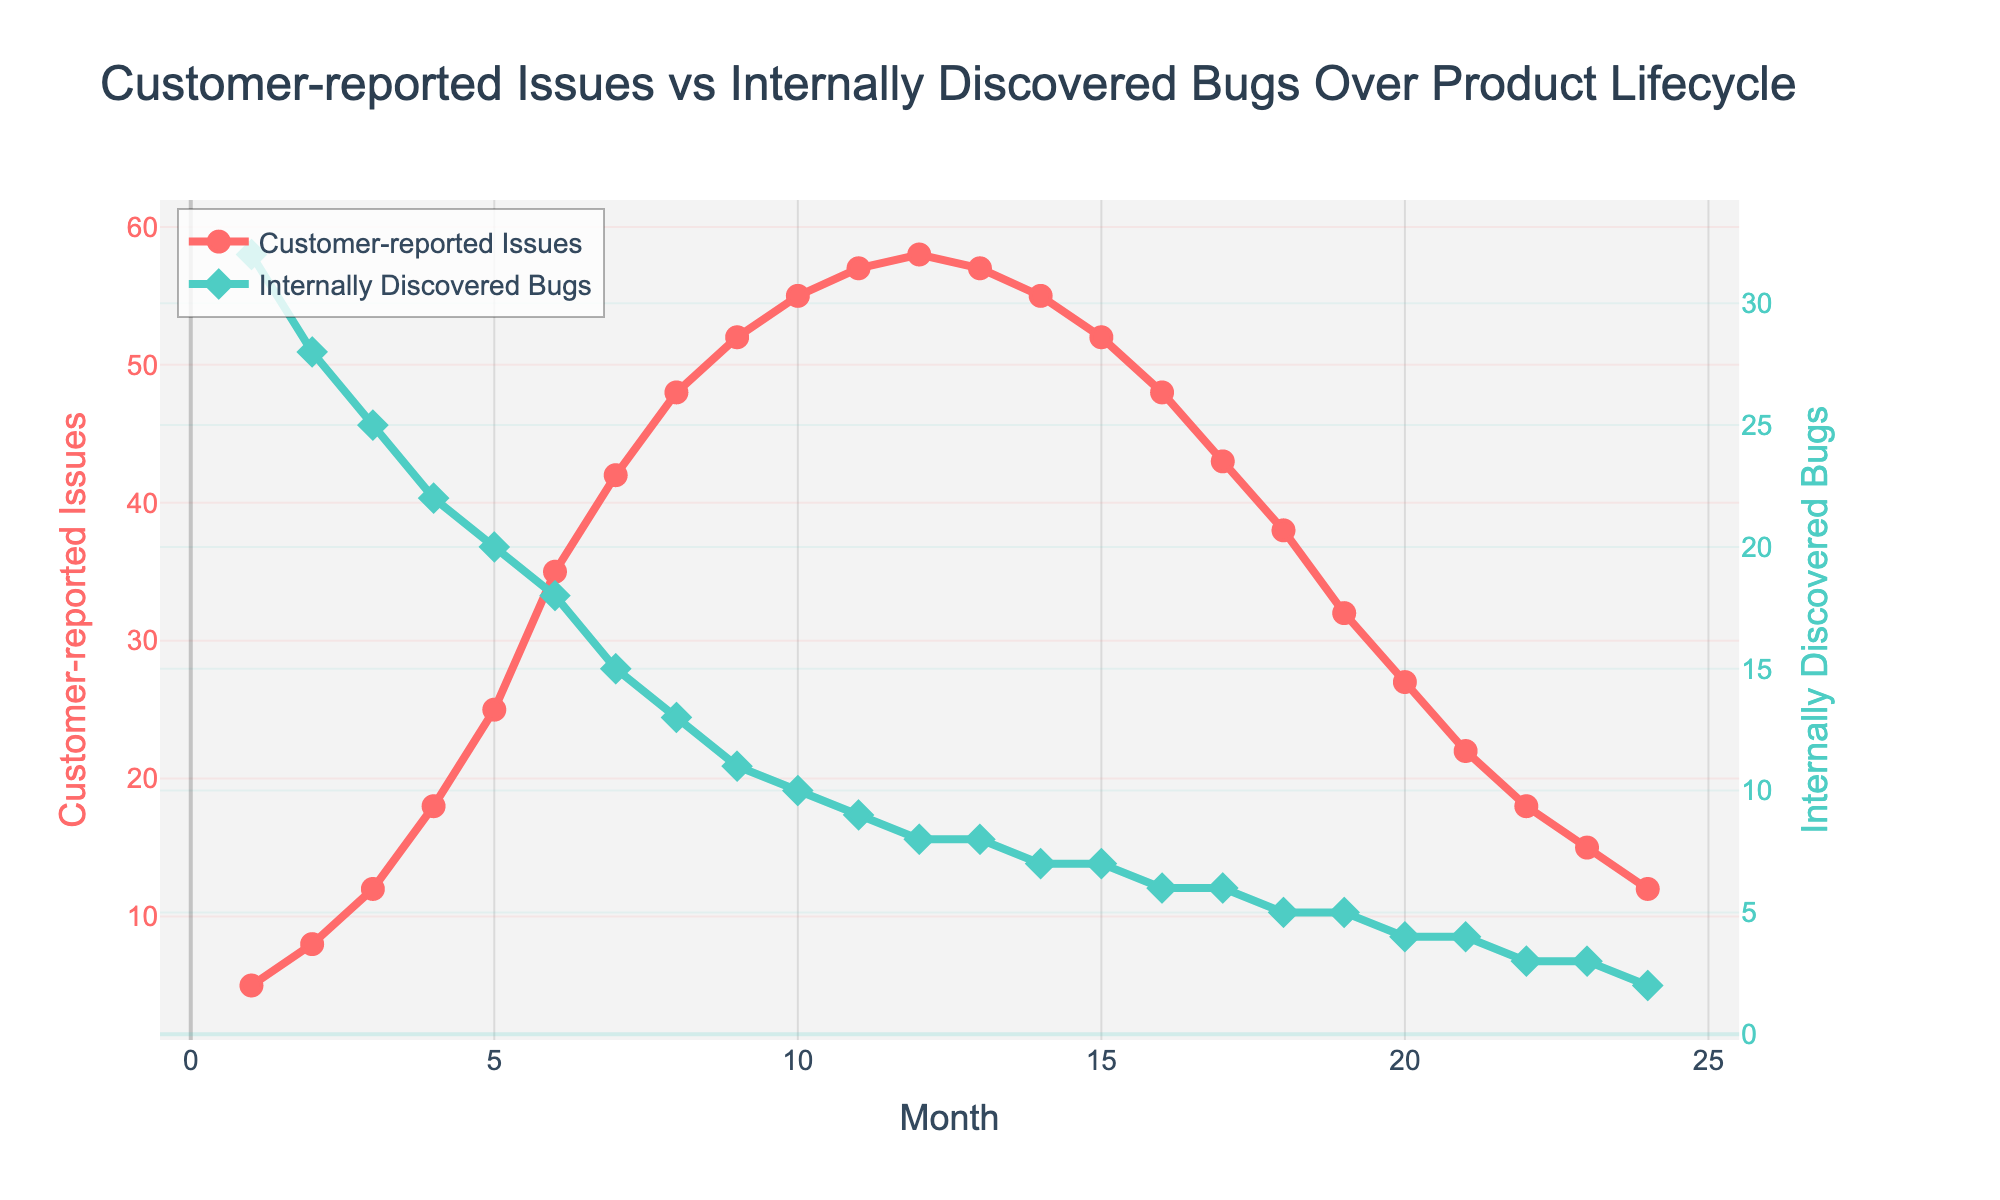What trend do we observe in customer-reported issues over the first 12 months? From the start (Month 1) to Month 12, customer-reported issues continuously increase from 5 to 58.
Answer: Continuous increase In which month does the number of internally discovered bugs fall below 10 for the first time? The internally discovered bugs drop below 10 for the first time in Month 11. At Month 11, the count is 9 bugs.
Answer: Month 11 What is the difference between the peak number of customer-reported issues and the lowest number of internally discovered bugs? The peak for customer-reported issues is 58 at Month 12, and the lowest number for internally discovered bugs is 2 at Month 24. The difference is 58 - 2 = 56.
Answer: 56 Which month has the maximum disparity between customer-reported issues and internally discovered bugs? The maximum disparity occurs in Month 12, where the customer-reported issues count is 58 and internally discovered bugs are 8. The disparity here is 58 - 8 = 50.
Answer: Month 12 Between which months do both customer-reported issues and internally discovered bugs decrease simultaneously for three consecutive months? Both customer-reported issues and internally discovered bugs decrease simultaneously between Months 14 and 16. For these months, customer-reported issues drop from 55 to 48 and internally discovered bugs drop from 7 to 6.
Answer: Months 14 to 16 What is the color used to represent internally discovered bugs on the graph? The color used to represent internally discovered bugs on the graph is green.
Answer: Green How does the trend of internally discovered bugs change from Month 13 to Month 24? From Month 13 to Month 24, the trend of internally discovered bugs shows a mostly declining pattern, reducing from 8 to 2.
Answer: Declining What is the visual representation (marker type) used for customer-reported issues, and how is it different from internally discovered bugs? Customer-reported issues are represented by circle markers, while internally discovered bugs are represented by diamond markers.
Answer: Circles for issues, diamonds for bugs In which month is the number of customer-reported issues exactly twice the number of internally discovered bugs? In Month 21, there are 22 customer-reported issues and 4 internally discovered bugs. 22 is exactly twice 4.
Answer: Month 21 